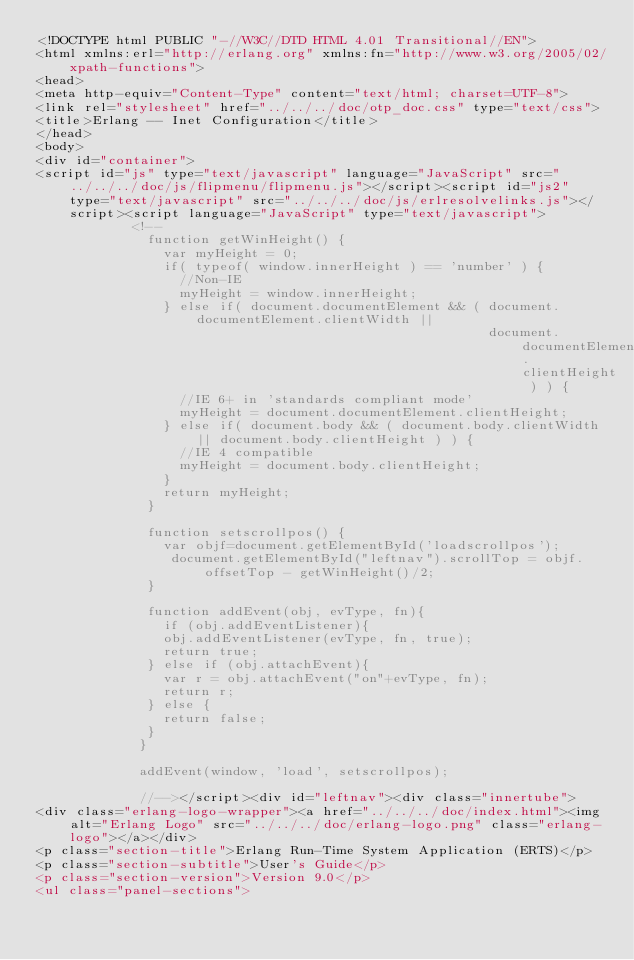Convert code to text. <code><loc_0><loc_0><loc_500><loc_500><_HTML_><!DOCTYPE html PUBLIC "-//W3C//DTD HTML 4.01 Transitional//EN">
<html xmlns:erl="http://erlang.org" xmlns:fn="http://www.w3.org/2005/02/xpath-functions">
<head>
<meta http-equiv="Content-Type" content="text/html; charset=UTF-8">
<link rel="stylesheet" href="../../../doc/otp_doc.css" type="text/css">
<title>Erlang -- Inet Configuration</title>
</head>
<body>
<div id="container">
<script id="js" type="text/javascript" language="JavaScript" src="../../../doc/js/flipmenu/flipmenu.js"></script><script id="js2" type="text/javascript" src="../../../doc/js/erlresolvelinks.js"></script><script language="JavaScript" type="text/javascript">
            <!--
              function getWinHeight() {
                var myHeight = 0;
                if( typeof( window.innerHeight ) == 'number' ) {
                  //Non-IE
                  myHeight = window.innerHeight;
                } else if( document.documentElement && ( document.documentElement.clientWidth ||
                                                         document.documentElement.clientHeight ) ) {
                  //IE 6+ in 'standards compliant mode'
                  myHeight = document.documentElement.clientHeight;
                } else if( document.body && ( document.body.clientWidth || document.body.clientHeight ) ) {
                  //IE 4 compatible
                  myHeight = document.body.clientHeight;
                }
                return myHeight;
              }

              function setscrollpos() {
                var objf=document.getElementById('loadscrollpos');
                 document.getElementById("leftnav").scrollTop = objf.offsetTop - getWinHeight()/2;
              }

              function addEvent(obj, evType, fn){
                if (obj.addEventListener){
                obj.addEventListener(evType, fn, true);
                return true;
              } else if (obj.attachEvent){
                var r = obj.attachEvent("on"+evType, fn);
                return r;
              } else {
                return false;
              }
             }

             addEvent(window, 'load', setscrollpos);

             //--></script><div id="leftnav"><div class="innertube">
<div class="erlang-logo-wrapper"><a href="../../../doc/index.html"><img alt="Erlang Logo" src="../../../doc/erlang-logo.png" class="erlang-logo"></a></div>
<p class="section-title">Erlang Run-Time System Application (ERTS)</p>
<p class="section-subtitle">User's Guide</p>
<p class="section-version">Version 9.0</p>
<ul class="panel-sections"></code> 